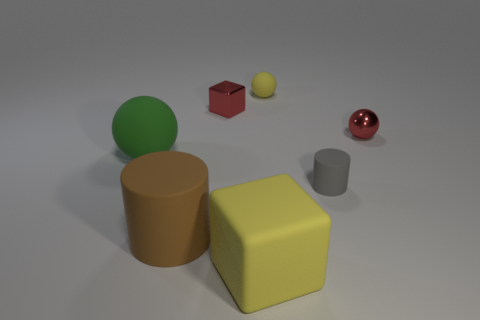There is a yellow thing that is the same material as the yellow block; what size is it?
Provide a short and direct response. Small. What is the brown cylinder made of?
Provide a succinct answer. Rubber. What number of yellow matte objects have the same size as the yellow matte cube?
Your answer should be compact. 0. The rubber thing that is the same color as the large block is what shape?
Your answer should be very brief. Sphere. Is there a tiny brown thing of the same shape as the big yellow object?
Make the answer very short. No. There is a cylinder that is the same size as the yellow block; what is its color?
Provide a short and direct response. Brown. There is a rubber ball that is left of the yellow block that is in front of the gray cylinder; what color is it?
Your response must be concise. Green. Is the color of the rubber sphere that is behind the red block the same as the tiny metal cube?
Ensure brevity in your answer.  No. What is the shape of the red shiny object that is on the left side of the cylinder that is right of the yellow rubber thing in front of the big brown object?
Provide a succinct answer. Cube. How many brown matte cylinders are behind the tiny thing to the right of the gray rubber object?
Give a very brief answer. 0. 